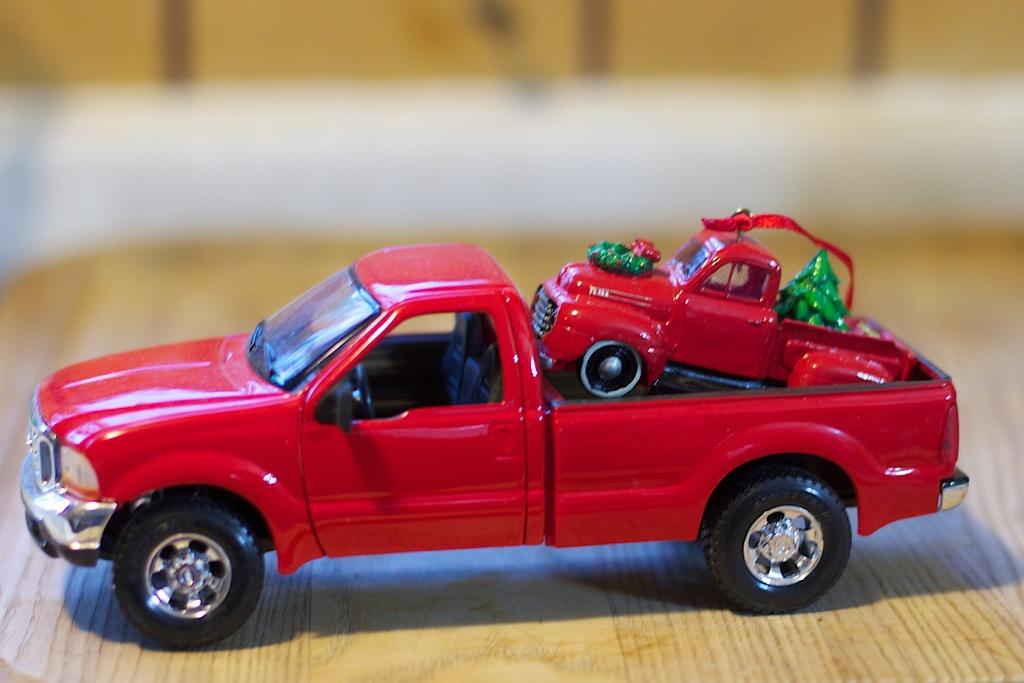What type of toys are present in the image? There are toy cars in the image. What is the surface on which the toy cars are placed? The toy cars are on a wooden surface. What type of crook is visible in the image? There is no crook present in the image; it features toy cars on a wooden surface. 